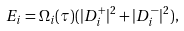<formula> <loc_0><loc_0><loc_500><loc_500>E _ { i } = \Omega _ { i } ( \tau ) ( | { D _ { i } ^ { + } } | ^ { 2 } + | { D _ { i } ^ { - } } | ^ { 2 } ) ,</formula> 